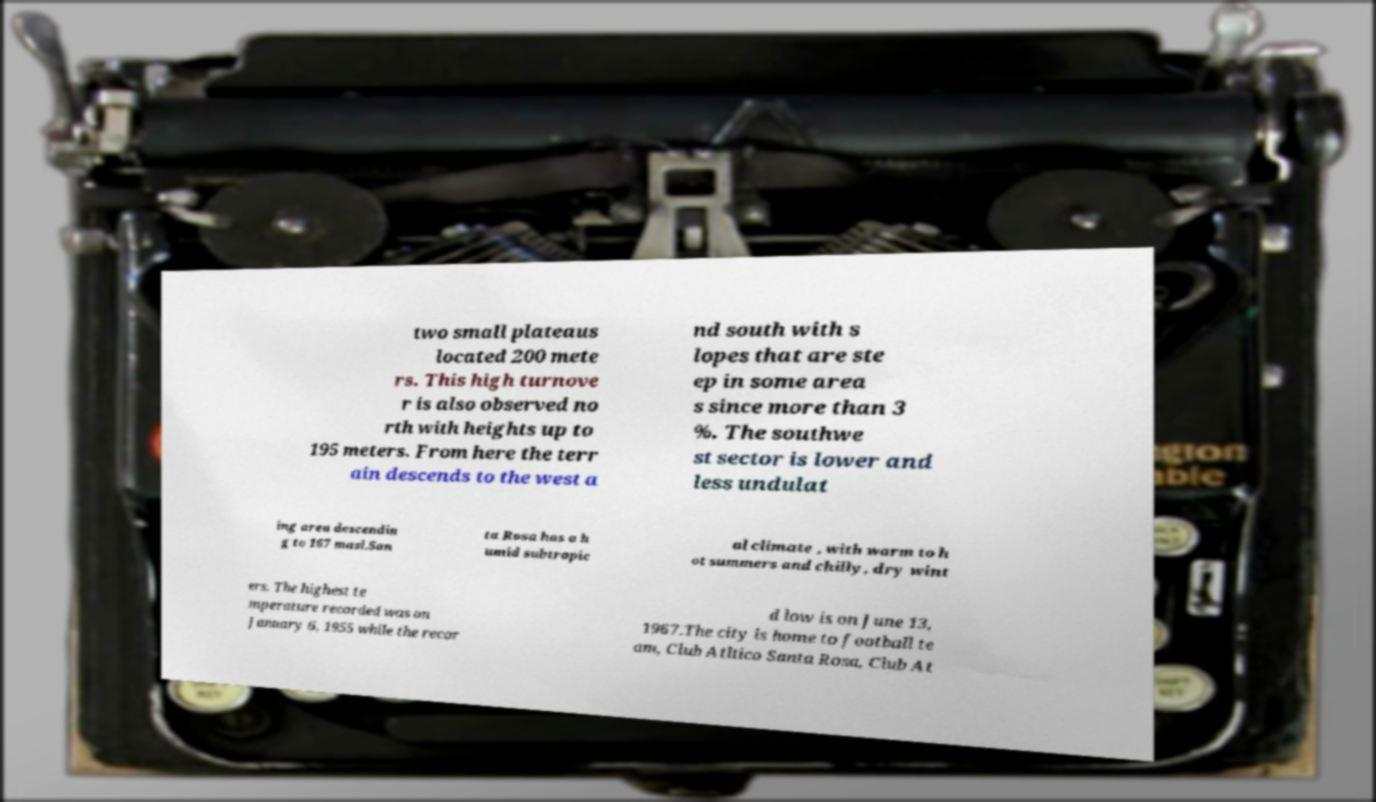Could you extract and type out the text from this image? two small plateaus located 200 mete rs. This high turnove r is also observed no rth with heights up to 195 meters. From here the terr ain descends to the west a nd south with s lopes that are ste ep in some area s since more than 3 %. The southwe st sector is lower and less undulat ing area descendin g to 167 masl.San ta Rosa has a h umid subtropic al climate , with warm to h ot summers and chilly, dry wint ers. The highest te mperature recorded was on January 6, 1955 while the recor d low is on June 13, 1967.The city is home to football te am, Club Atltico Santa Rosa, Club At 